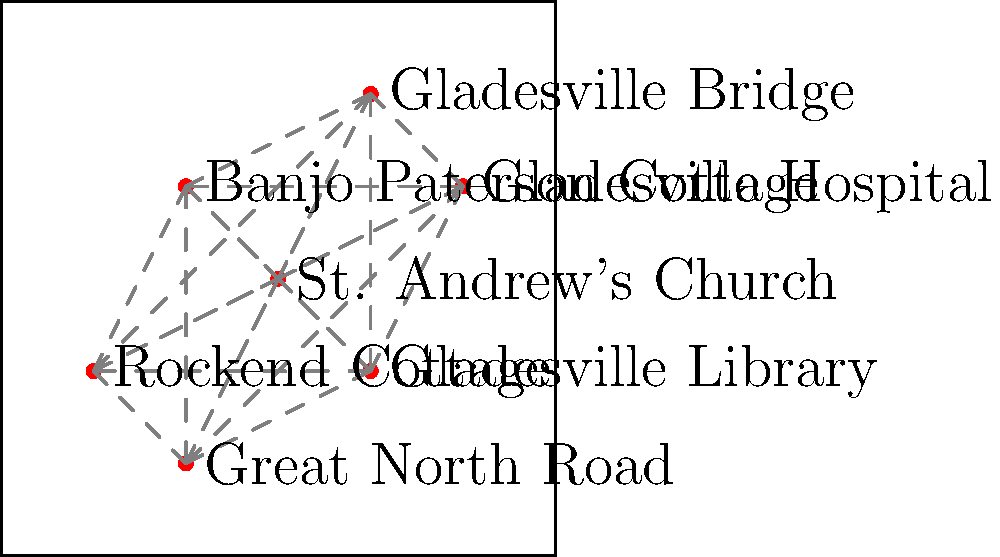Based on the network map of historical landmarks in Gladesville, which site appears to be the most centrally located and potentially serves as a hub for historical tourism in the area? To determine the most centrally located historical site, we need to consider the following steps:

1. Observe the distribution of landmarks on the map.
2. Identify which landmark has the most connections to other sites.
3. Consider the position of the landmark relative to others.

Analyzing the map:

1. St. Andrew's Church is located at the center of the map.
2. It has direct connections to all other landmarks.
3. Its central position allows for easy access to other historical sites.

Other landmarks:
- Gladesville Bridge is on the periphery.
- Banjo Paterson Cottage is slightly off-center.
- Gladesville Hospital is on the right side.
- Rockend Cottage is on the bottom left.
- Gladesville Library is on the bottom right.
- Great North Road is on the bottom.

St. Andrew's Church stands out as the most centrally located, with the most connections to other landmarks. This positioning makes it an ideal starting point for historical tours and a natural hub for exploring Gladesville's heritage.
Answer: St. Andrew's Church 